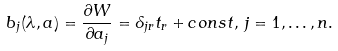Convert formula to latex. <formula><loc_0><loc_0><loc_500><loc_500>b _ { j } ( \lambda , a ) = \frac { \partial W } { \partial a _ { j } } = \delta _ { j r } t _ { r } + c o n s t , \, j = 1 , \dots , n .</formula> 